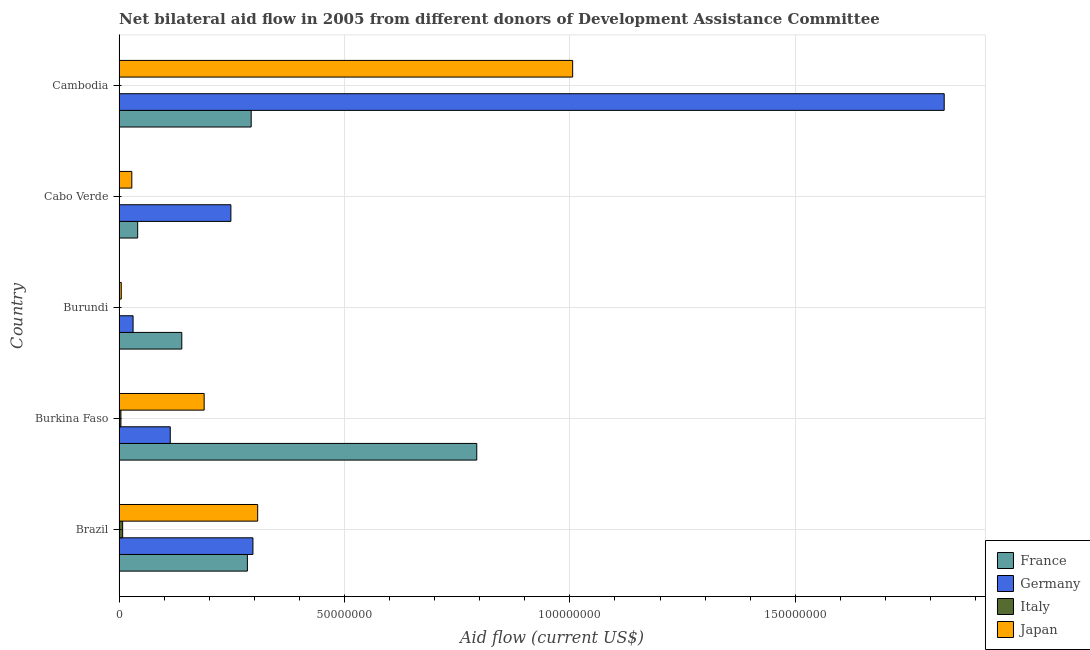How many different coloured bars are there?
Your response must be concise. 4. How many groups of bars are there?
Offer a very short reply. 5. Are the number of bars per tick equal to the number of legend labels?
Provide a succinct answer. No. How many bars are there on the 1st tick from the top?
Make the answer very short. 3. What is the label of the 4th group of bars from the top?
Make the answer very short. Burkina Faso. In how many cases, is the number of bars for a given country not equal to the number of legend labels?
Keep it short and to the point. 2. What is the amount of aid given by germany in Burkina Faso?
Offer a very short reply. 1.14e+07. Across all countries, what is the maximum amount of aid given by germany?
Offer a terse response. 1.83e+08. Across all countries, what is the minimum amount of aid given by france?
Keep it short and to the point. 4.13e+06. In which country was the amount of aid given by germany maximum?
Ensure brevity in your answer.  Cambodia. What is the total amount of aid given by japan in the graph?
Your answer should be compact. 1.54e+08. What is the difference between the amount of aid given by france in Cabo Verde and that in Cambodia?
Give a very brief answer. -2.52e+07. What is the difference between the amount of aid given by italy in Brazil and the amount of aid given by germany in Cabo Verde?
Keep it short and to the point. -2.40e+07. What is the average amount of aid given by italy per country?
Your answer should be very brief. 2.62e+05. What is the difference between the amount of aid given by france and amount of aid given by japan in Burundi?
Offer a very short reply. 1.34e+07. In how many countries, is the amount of aid given by germany greater than 90000000 US$?
Offer a terse response. 1. What is the ratio of the amount of aid given by germany in Burundi to that in Cambodia?
Provide a short and direct response. 0.02. Is the amount of aid given by france in Cabo Verde less than that in Cambodia?
Offer a terse response. Yes. What is the difference between the highest and the second highest amount of aid given by italy?
Give a very brief answer. 3.90e+05. What is the difference between the highest and the lowest amount of aid given by germany?
Offer a terse response. 1.80e+08. In how many countries, is the amount of aid given by germany greater than the average amount of aid given by germany taken over all countries?
Your answer should be very brief. 1. Is it the case that in every country, the sum of the amount of aid given by japan and amount of aid given by germany is greater than the sum of amount of aid given by france and amount of aid given by italy?
Make the answer very short. Yes. Is it the case that in every country, the sum of the amount of aid given by france and amount of aid given by germany is greater than the amount of aid given by italy?
Provide a succinct answer. Yes. Are all the bars in the graph horizontal?
Offer a very short reply. Yes. How many legend labels are there?
Your response must be concise. 4. How are the legend labels stacked?
Your response must be concise. Vertical. What is the title of the graph?
Your answer should be compact. Net bilateral aid flow in 2005 from different donors of Development Assistance Committee. Does "Custom duties" appear as one of the legend labels in the graph?
Provide a succinct answer. No. What is the label or title of the X-axis?
Provide a short and direct response. Aid flow (current US$). What is the Aid flow (current US$) in France in Brazil?
Your answer should be compact. 2.85e+07. What is the Aid flow (current US$) in Germany in Brazil?
Ensure brevity in your answer.  2.97e+07. What is the Aid flow (current US$) in Italy in Brazil?
Offer a terse response. 8.00e+05. What is the Aid flow (current US$) of Japan in Brazil?
Keep it short and to the point. 3.08e+07. What is the Aid flow (current US$) of France in Burkina Faso?
Your response must be concise. 7.94e+07. What is the Aid flow (current US$) of Germany in Burkina Faso?
Your response must be concise. 1.14e+07. What is the Aid flow (current US$) in Japan in Burkina Faso?
Offer a terse response. 1.89e+07. What is the Aid flow (current US$) in France in Burundi?
Give a very brief answer. 1.39e+07. What is the Aid flow (current US$) in Germany in Burundi?
Your response must be concise. 3.11e+06. What is the Aid flow (current US$) in France in Cabo Verde?
Provide a succinct answer. 4.13e+06. What is the Aid flow (current US$) in Germany in Cabo Verde?
Your answer should be very brief. 2.48e+07. What is the Aid flow (current US$) in Japan in Cabo Verde?
Make the answer very short. 2.83e+06. What is the Aid flow (current US$) of France in Cambodia?
Provide a short and direct response. 2.93e+07. What is the Aid flow (current US$) of Germany in Cambodia?
Keep it short and to the point. 1.83e+08. What is the Aid flow (current US$) in Japan in Cambodia?
Keep it short and to the point. 1.01e+08. Across all countries, what is the maximum Aid flow (current US$) in France?
Provide a succinct answer. 7.94e+07. Across all countries, what is the maximum Aid flow (current US$) in Germany?
Offer a very short reply. 1.83e+08. Across all countries, what is the maximum Aid flow (current US$) of Japan?
Your answer should be very brief. 1.01e+08. Across all countries, what is the minimum Aid flow (current US$) of France?
Provide a succinct answer. 4.13e+06. Across all countries, what is the minimum Aid flow (current US$) in Germany?
Keep it short and to the point. 3.11e+06. What is the total Aid flow (current US$) in France in the graph?
Keep it short and to the point. 1.55e+08. What is the total Aid flow (current US$) in Germany in the graph?
Keep it short and to the point. 2.52e+08. What is the total Aid flow (current US$) of Italy in the graph?
Make the answer very short. 1.31e+06. What is the total Aid flow (current US$) of Japan in the graph?
Make the answer very short. 1.54e+08. What is the difference between the Aid flow (current US$) of France in Brazil and that in Burkina Faso?
Your answer should be very brief. -5.09e+07. What is the difference between the Aid flow (current US$) of Germany in Brazil and that in Burkina Faso?
Offer a terse response. 1.83e+07. What is the difference between the Aid flow (current US$) in Italy in Brazil and that in Burkina Faso?
Provide a short and direct response. 3.90e+05. What is the difference between the Aid flow (current US$) in Japan in Brazil and that in Burkina Faso?
Offer a very short reply. 1.19e+07. What is the difference between the Aid flow (current US$) in France in Brazil and that in Burundi?
Ensure brevity in your answer.  1.46e+07. What is the difference between the Aid flow (current US$) of Germany in Brazil and that in Burundi?
Offer a very short reply. 2.66e+07. What is the difference between the Aid flow (current US$) of Japan in Brazil and that in Burundi?
Provide a succinct answer. 3.03e+07. What is the difference between the Aid flow (current US$) in France in Brazil and that in Cabo Verde?
Make the answer very short. 2.43e+07. What is the difference between the Aid flow (current US$) of Germany in Brazil and that in Cabo Verde?
Keep it short and to the point. 4.89e+06. What is the difference between the Aid flow (current US$) of Japan in Brazil and that in Cabo Verde?
Provide a short and direct response. 2.79e+07. What is the difference between the Aid flow (current US$) of France in Brazil and that in Cambodia?
Your answer should be compact. -8.40e+05. What is the difference between the Aid flow (current US$) of Germany in Brazil and that in Cambodia?
Provide a short and direct response. -1.53e+08. What is the difference between the Aid flow (current US$) in Japan in Brazil and that in Cambodia?
Give a very brief answer. -6.99e+07. What is the difference between the Aid flow (current US$) in France in Burkina Faso and that in Burundi?
Your response must be concise. 6.54e+07. What is the difference between the Aid flow (current US$) of Germany in Burkina Faso and that in Burundi?
Provide a short and direct response. 8.25e+06. What is the difference between the Aid flow (current US$) of Japan in Burkina Faso and that in Burundi?
Provide a short and direct response. 1.84e+07. What is the difference between the Aid flow (current US$) in France in Burkina Faso and that in Cabo Verde?
Give a very brief answer. 7.52e+07. What is the difference between the Aid flow (current US$) in Germany in Burkina Faso and that in Cabo Verde?
Give a very brief answer. -1.34e+07. What is the difference between the Aid flow (current US$) of Japan in Burkina Faso and that in Cabo Verde?
Your answer should be compact. 1.60e+07. What is the difference between the Aid flow (current US$) in France in Burkina Faso and that in Cambodia?
Offer a terse response. 5.00e+07. What is the difference between the Aid flow (current US$) in Germany in Burkina Faso and that in Cambodia?
Provide a succinct answer. -1.72e+08. What is the difference between the Aid flow (current US$) of Japan in Burkina Faso and that in Cambodia?
Your response must be concise. -8.17e+07. What is the difference between the Aid flow (current US$) in France in Burundi and that in Cabo Verde?
Keep it short and to the point. 9.79e+06. What is the difference between the Aid flow (current US$) of Germany in Burundi and that in Cabo Verde?
Your response must be concise. -2.17e+07. What is the difference between the Aid flow (current US$) of Japan in Burundi and that in Cabo Verde?
Your answer should be very brief. -2.34e+06. What is the difference between the Aid flow (current US$) of France in Burundi and that in Cambodia?
Your answer should be compact. -1.54e+07. What is the difference between the Aid flow (current US$) of Germany in Burundi and that in Cambodia?
Provide a succinct answer. -1.80e+08. What is the difference between the Aid flow (current US$) in Japan in Burundi and that in Cambodia?
Keep it short and to the point. -1.00e+08. What is the difference between the Aid flow (current US$) of France in Cabo Verde and that in Cambodia?
Keep it short and to the point. -2.52e+07. What is the difference between the Aid flow (current US$) of Germany in Cabo Verde and that in Cambodia?
Give a very brief answer. -1.58e+08. What is the difference between the Aid flow (current US$) in Japan in Cabo Verde and that in Cambodia?
Your response must be concise. -9.78e+07. What is the difference between the Aid flow (current US$) of France in Brazil and the Aid flow (current US$) of Germany in Burkina Faso?
Provide a succinct answer. 1.71e+07. What is the difference between the Aid flow (current US$) in France in Brazil and the Aid flow (current US$) in Italy in Burkina Faso?
Your answer should be compact. 2.81e+07. What is the difference between the Aid flow (current US$) of France in Brazil and the Aid flow (current US$) of Japan in Burkina Faso?
Offer a very short reply. 9.59e+06. What is the difference between the Aid flow (current US$) in Germany in Brazil and the Aid flow (current US$) in Italy in Burkina Faso?
Make the answer very short. 2.93e+07. What is the difference between the Aid flow (current US$) of Germany in Brazil and the Aid flow (current US$) of Japan in Burkina Faso?
Your answer should be compact. 1.08e+07. What is the difference between the Aid flow (current US$) of Italy in Brazil and the Aid flow (current US$) of Japan in Burkina Faso?
Keep it short and to the point. -1.81e+07. What is the difference between the Aid flow (current US$) in France in Brazil and the Aid flow (current US$) in Germany in Burundi?
Provide a succinct answer. 2.54e+07. What is the difference between the Aid flow (current US$) of France in Brazil and the Aid flow (current US$) of Italy in Burundi?
Offer a terse response. 2.84e+07. What is the difference between the Aid flow (current US$) of France in Brazil and the Aid flow (current US$) of Japan in Burundi?
Provide a short and direct response. 2.80e+07. What is the difference between the Aid flow (current US$) of Germany in Brazil and the Aid flow (current US$) of Italy in Burundi?
Make the answer very short. 2.96e+07. What is the difference between the Aid flow (current US$) in Germany in Brazil and the Aid flow (current US$) in Japan in Burundi?
Keep it short and to the point. 2.92e+07. What is the difference between the Aid flow (current US$) of France in Brazil and the Aid flow (current US$) of Germany in Cabo Verde?
Provide a short and direct response. 3.66e+06. What is the difference between the Aid flow (current US$) in France in Brazil and the Aid flow (current US$) in Japan in Cabo Verde?
Provide a short and direct response. 2.56e+07. What is the difference between the Aid flow (current US$) in Germany in Brazil and the Aid flow (current US$) in Japan in Cabo Verde?
Your answer should be very brief. 2.69e+07. What is the difference between the Aid flow (current US$) in Italy in Brazil and the Aid flow (current US$) in Japan in Cabo Verde?
Provide a short and direct response. -2.03e+06. What is the difference between the Aid flow (current US$) of France in Brazil and the Aid flow (current US$) of Germany in Cambodia?
Make the answer very short. -1.55e+08. What is the difference between the Aid flow (current US$) in France in Brazil and the Aid flow (current US$) in Japan in Cambodia?
Give a very brief answer. -7.22e+07. What is the difference between the Aid flow (current US$) in Germany in Brazil and the Aid flow (current US$) in Japan in Cambodia?
Offer a very short reply. -7.09e+07. What is the difference between the Aid flow (current US$) in Italy in Brazil and the Aid flow (current US$) in Japan in Cambodia?
Your answer should be compact. -9.98e+07. What is the difference between the Aid flow (current US$) of France in Burkina Faso and the Aid flow (current US$) of Germany in Burundi?
Offer a terse response. 7.62e+07. What is the difference between the Aid flow (current US$) of France in Burkina Faso and the Aid flow (current US$) of Italy in Burundi?
Your answer should be very brief. 7.92e+07. What is the difference between the Aid flow (current US$) in France in Burkina Faso and the Aid flow (current US$) in Japan in Burundi?
Offer a very short reply. 7.89e+07. What is the difference between the Aid flow (current US$) of Germany in Burkina Faso and the Aid flow (current US$) of Italy in Burundi?
Provide a short and direct response. 1.13e+07. What is the difference between the Aid flow (current US$) in Germany in Burkina Faso and the Aid flow (current US$) in Japan in Burundi?
Keep it short and to the point. 1.09e+07. What is the difference between the Aid flow (current US$) in France in Burkina Faso and the Aid flow (current US$) in Germany in Cabo Verde?
Offer a terse response. 5.45e+07. What is the difference between the Aid flow (current US$) in France in Burkina Faso and the Aid flow (current US$) in Japan in Cabo Verde?
Give a very brief answer. 7.65e+07. What is the difference between the Aid flow (current US$) in Germany in Burkina Faso and the Aid flow (current US$) in Japan in Cabo Verde?
Ensure brevity in your answer.  8.53e+06. What is the difference between the Aid flow (current US$) in Italy in Burkina Faso and the Aid flow (current US$) in Japan in Cabo Verde?
Your answer should be compact. -2.42e+06. What is the difference between the Aid flow (current US$) in France in Burkina Faso and the Aid flow (current US$) in Germany in Cambodia?
Offer a terse response. -1.04e+08. What is the difference between the Aid flow (current US$) of France in Burkina Faso and the Aid flow (current US$) of Japan in Cambodia?
Provide a short and direct response. -2.13e+07. What is the difference between the Aid flow (current US$) in Germany in Burkina Faso and the Aid flow (current US$) in Japan in Cambodia?
Your response must be concise. -8.93e+07. What is the difference between the Aid flow (current US$) in Italy in Burkina Faso and the Aid flow (current US$) in Japan in Cambodia?
Provide a succinct answer. -1.00e+08. What is the difference between the Aid flow (current US$) of France in Burundi and the Aid flow (current US$) of Germany in Cabo Verde?
Offer a very short reply. -1.09e+07. What is the difference between the Aid flow (current US$) of France in Burundi and the Aid flow (current US$) of Japan in Cabo Verde?
Offer a terse response. 1.11e+07. What is the difference between the Aid flow (current US$) in Germany in Burundi and the Aid flow (current US$) in Japan in Cabo Verde?
Keep it short and to the point. 2.80e+05. What is the difference between the Aid flow (current US$) in Italy in Burundi and the Aid flow (current US$) in Japan in Cabo Verde?
Give a very brief answer. -2.73e+06. What is the difference between the Aid flow (current US$) of France in Burundi and the Aid flow (current US$) of Germany in Cambodia?
Ensure brevity in your answer.  -1.69e+08. What is the difference between the Aid flow (current US$) of France in Burundi and the Aid flow (current US$) of Japan in Cambodia?
Ensure brevity in your answer.  -8.67e+07. What is the difference between the Aid flow (current US$) in Germany in Burundi and the Aid flow (current US$) in Japan in Cambodia?
Provide a succinct answer. -9.75e+07. What is the difference between the Aid flow (current US$) in Italy in Burundi and the Aid flow (current US$) in Japan in Cambodia?
Offer a very short reply. -1.01e+08. What is the difference between the Aid flow (current US$) of France in Cabo Verde and the Aid flow (current US$) of Germany in Cambodia?
Make the answer very short. -1.79e+08. What is the difference between the Aid flow (current US$) in France in Cabo Verde and the Aid flow (current US$) in Japan in Cambodia?
Provide a short and direct response. -9.65e+07. What is the difference between the Aid flow (current US$) in Germany in Cabo Verde and the Aid flow (current US$) in Japan in Cambodia?
Offer a terse response. -7.58e+07. What is the average Aid flow (current US$) in France per country?
Make the answer very short. 3.10e+07. What is the average Aid flow (current US$) of Germany per country?
Ensure brevity in your answer.  5.04e+07. What is the average Aid flow (current US$) of Italy per country?
Give a very brief answer. 2.62e+05. What is the average Aid flow (current US$) in Japan per country?
Your response must be concise. 3.07e+07. What is the difference between the Aid flow (current US$) in France and Aid flow (current US$) in Germany in Brazil?
Make the answer very short. -1.23e+06. What is the difference between the Aid flow (current US$) in France and Aid flow (current US$) in Italy in Brazil?
Your answer should be compact. 2.77e+07. What is the difference between the Aid flow (current US$) of France and Aid flow (current US$) of Japan in Brazil?
Offer a terse response. -2.28e+06. What is the difference between the Aid flow (current US$) of Germany and Aid flow (current US$) of Italy in Brazil?
Provide a succinct answer. 2.89e+07. What is the difference between the Aid flow (current US$) in Germany and Aid flow (current US$) in Japan in Brazil?
Your answer should be compact. -1.05e+06. What is the difference between the Aid flow (current US$) of Italy and Aid flow (current US$) of Japan in Brazil?
Make the answer very short. -3.00e+07. What is the difference between the Aid flow (current US$) of France and Aid flow (current US$) of Germany in Burkina Faso?
Give a very brief answer. 6.80e+07. What is the difference between the Aid flow (current US$) in France and Aid flow (current US$) in Italy in Burkina Faso?
Your answer should be compact. 7.89e+07. What is the difference between the Aid flow (current US$) of France and Aid flow (current US$) of Japan in Burkina Faso?
Your response must be concise. 6.05e+07. What is the difference between the Aid flow (current US$) in Germany and Aid flow (current US$) in Italy in Burkina Faso?
Offer a terse response. 1.10e+07. What is the difference between the Aid flow (current US$) of Germany and Aid flow (current US$) of Japan in Burkina Faso?
Keep it short and to the point. -7.52e+06. What is the difference between the Aid flow (current US$) of Italy and Aid flow (current US$) of Japan in Burkina Faso?
Offer a terse response. -1.85e+07. What is the difference between the Aid flow (current US$) of France and Aid flow (current US$) of Germany in Burundi?
Provide a succinct answer. 1.08e+07. What is the difference between the Aid flow (current US$) in France and Aid flow (current US$) in Italy in Burundi?
Your response must be concise. 1.38e+07. What is the difference between the Aid flow (current US$) of France and Aid flow (current US$) of Japan in Burundi?
Keep it short and to the point. 1.34e+07. What is the difference between the Aid flow (current US$) of Germany and Aid flow (current US$) of Italy in Burundi?
Offer a terse response. 3.01e+06. What is the difference between the Aid flow (current US$) of Germany and Aid flow (current US$) of Japan in Burundi?
Ensure brevity in your answer.  2.62e+06. What is the difference between the Aid flow (current US$) in Italy and Aid flow (current US$) in Japan in Burundi?
Give a very brief answer. -3.90e+05. What is the difference between the Aid flow (current US$) of France and Aid flow (current US$) of Germany in Cabo Verde?
Ensure brevity in your answer.  -2.07e+07. What is the difference between the Aid flow (current US$) of France and Aid flow (current US$) of Japan in Cabo Verde?
Provide a succinct answer. 1.30e+06. What is the difference between the Aid flow (current US$) of Germany and Aid flow (current US$) of Japan in Cabo Verde?
Offer a terse response. 2.20e+07. What is the difference between the Aid flow (current US$) of France and Aid flow (current US$) of Germany in Cambodia?
Provide a succinct answer. -1.54e+08. What is the difference between the Aid flow (current US$) of France and Aid flow (current US$) of Japan in Cambodia?
Keep it short and to the point. -7.13e+07. What is the difference between the Aid flow (current US$) in Germany and Aid flow (current US$) in Japan in Cambodia?
Provide a succinct answer. 8.24e+07. What is the ratio of the Aid flow (current US$) of France in Brazil to that in Burkina Faso?
Your response must be concise. 0.36. What is the ratio of the Aid flow (current US$) of Germany in Brazil to that in Burkina Faso?
Offer a very short reply. 2.61. What is the ratio of the Aid flow (current US$) of Italy in Brazil to that in Burkina Faso?
Your response must be concise. 1.95. What is the ratio of the Aid flow (current US$) in Japan in Brazil to that in Burkina Faso?
Give a very brief answer. 1.63. What is the ratio of the Aid flow (current US$) of France in Brazil to that in Burundi?
Ensure brevity in your answer.  2.05. What is the ratio of the Aid flow (current US$) of Germany in Brazil to that in Burundi?
Your response must be concise. 9.55. What is the ratio of the Aid flow (current US$) in Japan in Brazil to that in Burundi?
Offer a terse response. 62.76. What is the ratio of the Aid flow (current US$) in France in Brazil to that in Cabo Verde?
Provide a short and direct response. 6.89. What is the ratio of the Aid flow (current US$) in Germany in Brazil to that in Cabo Verde?
Provide a short and direct response. 1.2. What is the ratio of the Aid flow (current US$) of Japan in Brazil to that in Cabo Verde?
Give a very brief answer. 10.87. What is the ratio of the Aid flow (current US$) in France in Brazil to that in Cambodia?
Your answer should be very brief. 0.97. What is the ratio of the Aid flow (current US$) of Germany in Brazil to that in Cambodia?
Your answer should be compact. 0.16. What is the ratio of the Aid flow (current US$) of Japan in Brazil to that in Cambodia?
Make the answer very short. 0.31. What is the ratio of the Aid flow (current US$) in France in Burkina Faso to that in Burundi?
Your response must be concise. 5.7. What is the ratio of the Aid flow (current US$) in Germany in Burkina Faso to that in Burundi?
Offer a terse response. 3.65. What is the ratio of the Aid flow (current US$) of Japan in Burkina Faso to that in Burundi?
Make the answer very short. 38.53. What is the ratio of the Aid flow (current US$) in France in Burkina Faso to that in Cabo Verde?
Provide a short and direct response. 19.21. What is the ratio of the Aid flow (current US$) in Germany in Burkina Faso to that in Cabo Verde?
Provide a succinct answer. 0.46. What is the ratio of the Aid flow (current US$) of Japan in Burkina Faso to that in Cabo Verde?
Provide a succinct answer. 6.67. What is the ratio of the Aid flow (current US$) in France in Burkina Faso to that in Cambodia?
Offer a terse response. 2.71. What is the ratio of the Aid flow (current US$) of Germany in Burkina Faso to that in Cambodia?
Give a very brief answer. 0.06. What is the ratio of the Aid flow (current US$) of Japan in Burkina Faso to that in Cambodia?
Provide a short and direct response. 0.19. What is the ratio of the Aid flow (current US$) in France in Burundi to that in Cabo Verde?
Offer a very short reply. 3.37. What is the ratio of the Aid flow (current US$) in Germany in Burundi to that in Cabo Verde?
Offer a terse response. 0.13. What is the ratio of the Aid flow (current US$) of Japan in Burundi to that in Cabo Verde?
Give a very brief answer. 0.17. What is the ratio of the Aid flow (current US$) of France in Burundi to that in Cambodia?
Offer a very short reply. 0.47. What is the ratio of the Aid flow (current US$) in Germany in Burundi to that in Cambodia?
Ensure brevity in your answer.  0.02. What is the ratio of the Aid flow (current US$) of Japan in Burundi to that in Cambodia?
Offer a very short reply. 0. What is the ratio of the Aid flow (current US$) of France in Cabo Verde to that in Cambodia?
Offer a very short reply. 0.14. What is the ratio of the Aid flow (current US$) in Germany in Cabo Verde to that in Cambodia?
Your response must be concise. 0.14. What is the ratio of the Aid flow (current US$) in Japan in Cabo Verde to that in Cambodia?
Ensure brevity in your answer.  0.03. What is the difference between the highest and the second highest Aid flow (current US$) of France?
Make the answer very short. 5.00e+07. What is the difference between the highest and the second highest Aid flow (current US$) of Germany?
Offer a terse response. 1.53e+08. What is the difference between the highest and the second highest Aid flow (current US$) of Italy?
Your answer should be very brief. 3.90e+05. What is the difference between the highest and the second highest Aid flow (current US$) of Japan?
Provide a short and direct response. 6.99e+07. What is the difference between the highest and the lowest Aid flow (current US$) in France?
Offer a very short reply. 7.52e+07. What is the difference between the highest and the lowest Aid flow (current US$) of Germany?
Give a very brief answer. 1.80e+08. What is the difference between the highest and the lowest Aid flow (current US$) of Japan?
Your response must be concise. 1.00e+08. 